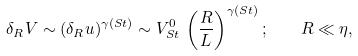<formula> <loc_0><loc_0><loc_500><loc_500>\delta _ { R } V \sim ( \delta _ { R } u ) ^ { \gamma ( S t ) } \sim V ^ { 0 } _ { S t } \, \left ( \frac { R } { L } \right ) ^ { \gamma ( S t ) } ; \quad R \ll \eta ,</formula> 